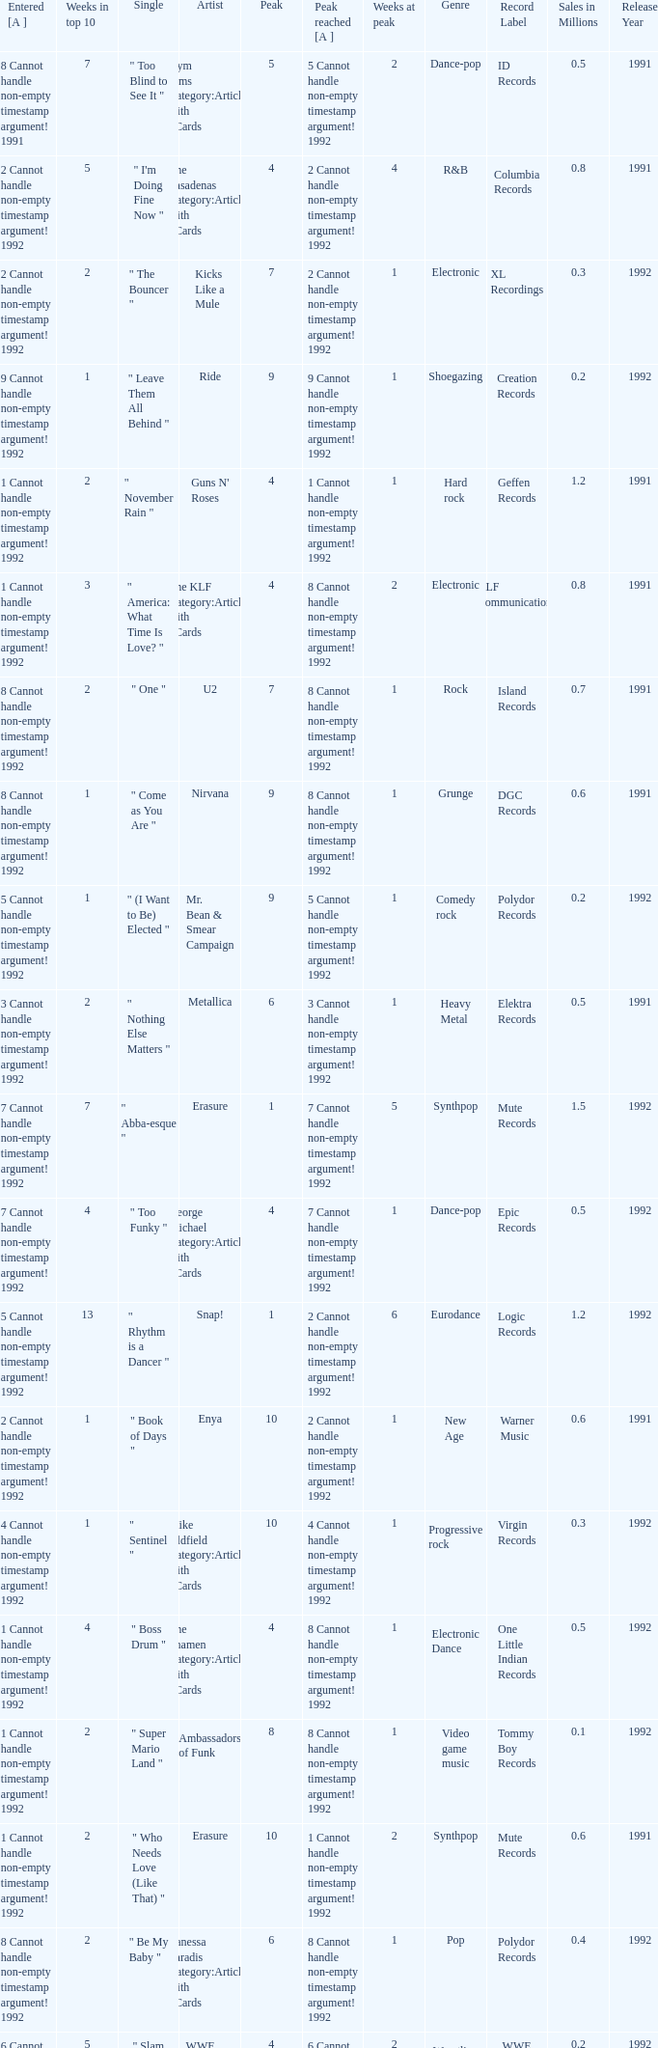If the peak reached is 6 cannot handle non-empty timestamp argument! 1992, what is the entered? 6 Cannot handle non-empty timestamp argument! 1992. 